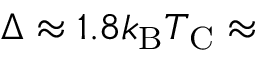Convert formula to latex. <formula><loc_0><loc_0><loc_500><loc_500>\Delta \approx 1 . 8 k _ { B } T _ { C } \approx</formula> 